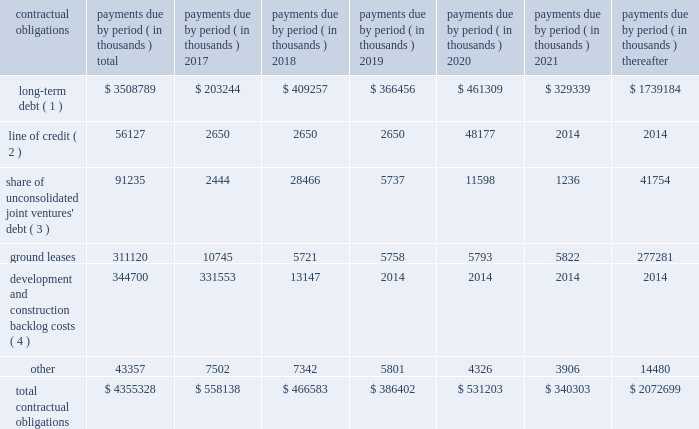
( 1 ) our long-term debt consists of both secured and unsecured debt and includes both principal and interest .
Interest payments for variable rate debt were calculated using the interest rates as of december 31 , 2016 .
Repayment of our $ 250.0 million variable rate term note , which has a contractual maturity date in january 2019 , is reflected as a 2020 obligation in the table above based on the ability to exercise a one-year extension , which we may exercise at our discretion .
( 2 ) our unsecured line of credit has a contractual maturity date in january 2019 , but is reflected as a 2020 obligation in the table above based on the ability to exercise a one-year extension , which we may exercise at our discretion .
Interest payments for our unsecured line of credit were calculated using the most recent stated interest rate that was in effect.ff ( 3 ) our share of unconsolidated joint venture debt includes both principal and interest .
Interest expense for variable rate debt was calculated using the interest rate at december 31 , 2016 .
( 4 ) represents estimated remaining costs on the completion of owned development projects and third-party construction projects .
Related party y transactionstt we provide property and asset management , leasing , construction and other tenant-related services to ww unconsolidated companies in which we have equity interests .
For the years ended december 31 , 2016 , 2015 and 2014 we earned management fees of $ 4.5 million , $ 6.8 million and $ 8.5 million , leasing fees of $ 2.4 million , $ 3.0 million and $ 3.4 million and construction and development fees of $ 8.0 million , $ 6.1 million and $ 5.8 million , respectively , from these companies , prior to elimination of our ownership percentage .
Yy we recorded these fees based ww on contractual terms that approximate market rates for these types of services and have eliminated our ownership percentages of these fees in the consolidated financial statements .
Commitments and contingenciesg the partnership has guaranteed the repayment of $ 32.9 million of economic development bonds issued by various municipalities in connection with certain commercial developments .
We will be required to make payments under ww our guarantees to the extent that incremental taxes from specified developments are not sufficient to pay the bond ff debt service .
Management does not believe that it is probable that we will be required to make any significant payments in satisfaction of these guarantees .
The partnership also has guaranteed the repayment of an unsecured loan of one of our unconsolidated subsidiaries .
At december 31 , 2016 , the maximum guarantee exposure for this loan was approximately $ 52.1 million .
We lease certain land positions with terms extending toww march 2114 , with a total future payment obligation of $ 311.1 million .
The payments on these ground leases , which are classified as operating leases , are not material in any individual year .
In addition to ground leases , we are party to other operating leases as part of conducting our business , including leases of office space from third parties , with a total future payment obligation of ff $ 43.4 million at december 31 , 2016 .
No future payments on these leases are material in any individual year .
We are subject to various legal proceedings and claims that arise in the ordinary course of business .
In the opinion ww of management , the amount of any ultimate liability with respect to these actions is not expected to materially affect ff our consolidated financial statements or results of operations .
We own certain parcels of land that are subject to special property tax assessments levied by quasi municipalww entities .
To the extent that such special assessments are fixed and determinable , the discounted value of the fulltt .
What is the long term debt as a percentage of total contractual obligations in 2017? 
Computations: ((203244 / 558138) * 100)
Answer: 36.41465. 
( 1 ) our long-term debt consists of both secured and unsecured debt and includes both principal and interest .
Interest payments for variable rate debt were calculated using the interest rates as of december 31 , 2016 .
Repayment of our $ 250.0 million variable rate term note , which has a contractual maturity date in january 2019 , is reflected as a 2020 obligation in the table above based on the ability to exercise a one-year extension , which we may exercise at our discretion .
( 2 ) our unsecured line of credit has a contractual maturity date in january 2019 , but is reflected as a 2020 obligation in the table above based on the ability to exercise a one-year extension , which we may exercise at our discretion .
Interest payments for our unsecured line of credit were calculated using the most recent stated interest rate that was in effect.ff ( 3 ) our share of unconsolidated joint venture debt includes both principal and interest .
Interest expense for variable rate debt was calculated using the interest rate at december 31 , 2016 .
( 4 ) represents estimated remaining costs on the completion of owned development projects and third-party construction projects .
Related party y transactionstt we provide property and asset management , leasing , construction and other tenant-related services to ww unconsolidated companies in which we have equity interests .
For the years ended december 31 , 2016 , 2015 and 2014 we earned management fees of $ 4.5 million , $ 6.8 million and $ 8.5 million , leasing fees of $ 2.4 million , $ 3.0 million and $ 3.4 million and construction and development fees of $ 8.0 million , $ 6.1 million and $ 5.8 million , respectively , from these companies , prior to elimination of our ownership percentage .
Yy we recorded these fees based ww on contractual terms that approximate market rates for these types of services and have eliminated our ownership percentages of these fees in the consolidated financial statements .
Commitments and contingenciesg the partnership has guaranteed the repayment of $ 32.9 million of economic development bonds issued by various municipalities in connection with certain commercial developments .
We will be required to make payments under ww our guarantees to the extent that incremental taxes from specified developments are not sufficient to pay the bond ff debt service .
Management does not believe that it is probable that we will be required to make any significant payments in satisfaction of these guarantees .
The partnership also has guaranteed the repayment of an unsecured loan of one of our unconsolidated subsidiaries .
At december 31 , 2016 , the maximum guarantee exposure for this loan was approximately $ 52.1 million .
We lease certain land positions with terms extending toww march 2114 , with a total future payment obligation of $ 311.1 million .
The payments on these ground leases , which are classified as operating leases , are not material in any individual year .
In addition to ground leases , we are party to other operating leases as part of conducting our business , including leases of office space from third parties , with a total future payment obligation of ff $ 43.4 million at december 31 , 2016 .
No future payments on these leases are material in any individual year .
We are subject to various legal proceedings and claims that arise in the ordinary course of business .
In the opinion ww of management , the amount of any ultimate liability with respect to these actions is not expected to materially affect ff our consolidated financial statements or results of operations .
We own certain parcels of land that are subject to special property tax assessments levied by quasi municipalww entities .
To the extent that such special assessments are fixed and determinable , the discounted value of the fulltt .
What is the percent change in management fees earned from 2015 to 2016? 
Computations: (((6.8 - 4.5) / 4.5) * 100)
Answer: 51.11111. 